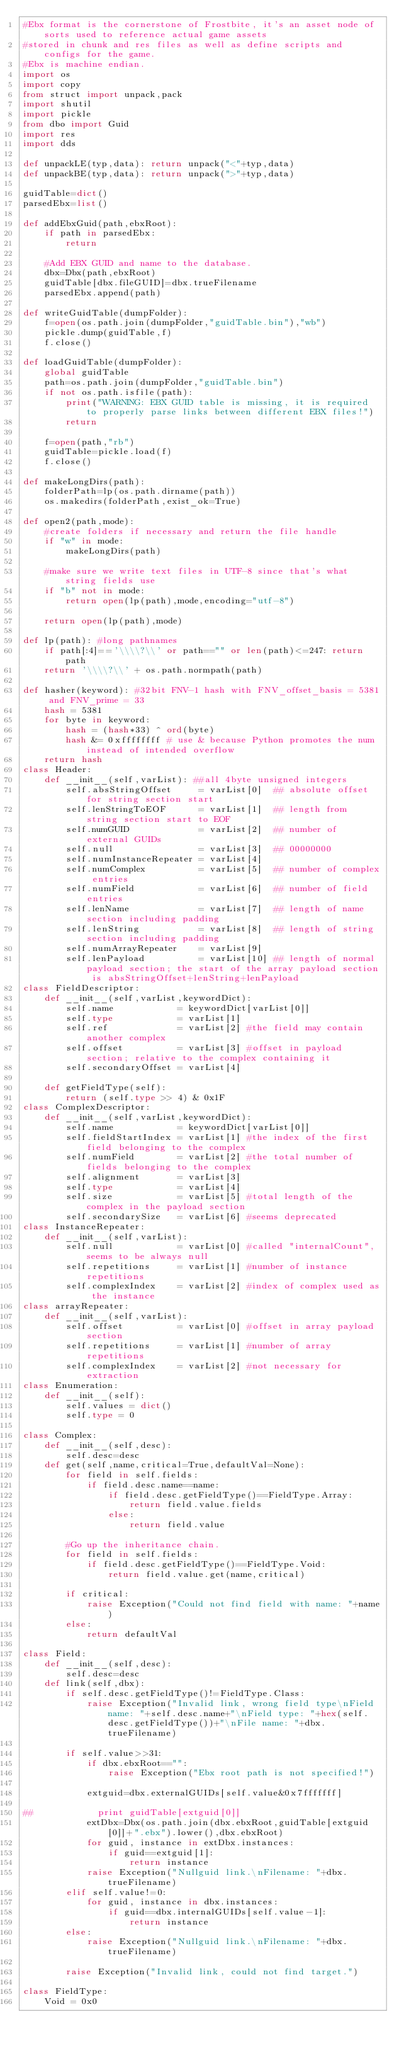<code> <loc_0><loc_0><loc_500><loc_500><_Python_>#Ebx format is the cornerstone of Frostbite, it's an asset node of sorts used to reference actual game assets
#stored in chunk and res files as well as define scripts and configs for the game.
#Ebx is machine endian.
import os
import copy
from struct import unpack,pack
import shutil
import pickle
from dbo import Guid
import res
import dds

def unpackLE(typ,data): return unpack("<"+typ,data)
def unpackBE(typ,data): return unpack(">"+typ,data)

guidTable=dict()
parsedEbx=list()

def addEbxGuid(path,ebxRoot):
    if path in parsedEbx:
        return

    #Add EBX GUID and name to the database.
    dbx=Dbx(path,ebxRoot)
    guidTable[dbx.fileGUID]=dbx.trueFilename
    parsedEbx.append(path)

def writeGuidTable(dumpFolder):
    f=open(os.path.join(dumpFolder,"guidTable.bin"),"wb")
    pickle.dump(guidTable,f)
    f.close()

def loadGuidTable(dumpFolder):
    global guidTable
    path=os.path.join(dumpFolder,"guidTable.bin")
    if not os.path.isfile(path):
        print("WARNING: EBX GUID table is missing, it is required to properly parse links between different EBX files!")
        return

    f=open(path,"rb")
    guidTable=pickle.load(f)
    f.close()

def makeLongDirs(path):
    folderPath=lp(os.path.dirname(path))
    os.makedirs(folderPath,exist_ok=True)

def open2(path,mode):
    #create folders if necessary and return the file handle
    if "w" in mode:
        makeLongDirs(path)

    #make sure we write text files in UTF-8 since that's what string fields use
    if "b" not in mode:
        return open(lp(path),mode,encoding="utf-8")

    return open(lp(path),mode)

def lp(path): #long pathnames
    if path[:4]=='\\\\?\\' or path=="" or len(path)<=247: return path
    return '\\\\?\\' + os.path.normpath(path)

def hasher(keyword): #32bit FNV-1 hash with FNV_offset_basis = 5381 and FNV_prime = 33
    hash = 5381
    for byte in keyword:
        hash = (hash*33) ^ ord(byte)
        hash &= 0xffffffff # use & because Python promotes the num instead of intended overflow
    return hash
class Header:
    def __init__(self,varList): ##all 4byte unsigned integers
        self.absStringOffset     = varList[0]  ## absolute offset for string section start
        self.lenStringToEOF      = varList[1]  ## length from string section start to EOF
        self.numGUID             = varList[2]  ## number of external GUIDs
        self.null                = varList[3]  ## 00000000
        self.numInstanceRepeater = varList[4]
        self.numComplex          = varList[5]  ## number of complex entries
        self.numField            = varList[6]  ## number of field entries
        self.lenName             = varList[7]  ## length of name section including padding
        self.lenString           = varList[8]  ## length of string section including padding
        self.numArrayRepeater    = varList[9]
        self.lenPayload          = varList[10] ## length of normal payload section; the start of the array payload section is absStringOffset+lenString+lenPayload
class FieldDescriptor:
    def __init__(self,varList,keywordDict):
        self.name            = keywordDict[varList[0]]
        self.type            = varList[1]
        self.ref             = varList[2] #the field may contain another complex
        self.offset          = varList[3] #offset in payload section; relative to the complex containing it
        self.secondaryOffset = varList[4]

    def getFieldType(self):
        return (self.type >> 4) & 0x1F
class ComplexDescriptor:
    def __init__(self,varList,keywordDict):
        self.name            = keywordDict[varList[0]]
        self.fieldStartIndex = varList[1] #the index of the first field belonging to the complex
        self.numField        = varList[2] #the total number of fields belonging to the complex
        self.alignment       = varList[3]
        self.type            = varList[4]
        self.size            = varList[5] #total length of the complex in the payload section
        self.secondarySize   = varList[6] #seems deprecated
class InstanceRepeater:
    def __init__(self,varList):
        self.null            = varList[0] #called "internalCount", seems to be always null
        self.repetitions     = varList[1] #number of instance repetitions
        self.complexIndex    = varList[2] #index of complex used as the instance
class arrayRepeater:
    def __init__(self,varList):
        self.offset          = varList[0] #offset in array payload section
        self.repetitions     = varList[1] #number of array repetitions
        self.complexIndex    = varList[2] #not necessary for extraction
class Enumeration:
    def __init__(self):
        self.values = dict()
        self.type = 0

class Complex:
    def __init__(self,desc):
        self.desc=desc
    def get(self,name,critical=True,defaultVal=None):
        for field in self.fields:
            if field.desc.name==name:
                if field.desc.getFieldType()==FieldType.Array:
                    return field.value.fields
                else:
                    return field.value

        #Go up the inheritance chain.
        for field in self.fields:
            if field.desc.getFieldType()==FieldType.Void:
                return field.value.get(name,critical)

        if critical:
            raise Exception("Could not find field with name: "+name)
        else:
            return defaultVal

class Field:
    def __init__(self,desc):
        self.desc=desc
    def link(self,dbx):
        if self.desc.getFieldType()!=FieldType.Class:
            raise Exception("Invalid link, wrong field type\nField name: "+self.desc.name+"\nField type: "+hex(self.desc.getFieldType())+"\nFile name: "+dbx.trueFilename)

        if self.value>>31:
            if dbx.ebxRoot=="":
                raise Exception("Ebx root path is not specified!")

            extguid=dbx.externalGUIDs[self.value&0x7fffffff]

##            print guidTable[extguid[0]]
            extDbx=Dbx(os.path.join(dbx.ebxRoot,guidTable[extguid[0]]+".ebx").lower(),dbx.ebxRoot)
            for guid, instance in extDbx.instances:
                if guid==extguid[1]:
                    return instance
            raise Exception("Nullguid link.\nFilename: "+dbx.trueFilename)
        elif self.value!=0:
            for guid, instance in dbx.instances:
                if guid==dbx.internalGUIDs[self.value-1]:
                    return instance
        else:
            raise Exception("Nullguid link.\nFilename: "+dbx.trueFilename)

        raise Exception("Invalid link, could not find target.")

class FieldType:
    Void = 0x0</code> 